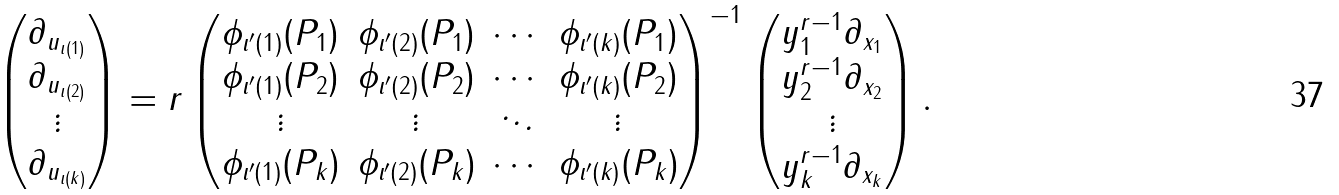<formula> <loc_0><loc_0><loc_500><loc_500>\left ( \begin{matrix} \partial _ { u _ { \iota ( 1 ) } } \\ \partial _ { u _ { \iota ( 2 ) } } \\ \vdots \\ \partial _ { u _ { \iota ( k ) } } \end{matrix} \right ) = r \left ( \begin{matrix} \phi _ { \iota ^ { \prime } ( 1 ) } ( P _ { 1 } ) & \phi _ { \iota ^ { \prime } ( 2 ) } ( P _ { 1 } ) & \cdots & \phi _ { \iota ^ { \prime } ( k ) } ( P _ { 1 } ) \\ \phi _ { \iota ^ { \prime } ( 1 ) } ( P _ { 2 } ) & \phi _ { \iota ^ { \prime } ( 2 ) } ( P _ { 2 } ) & \cdots & \phi _ { \iota ^ { \prime } ( k ) } ( P _ { 2 } ) \\ \vdots & \vdots & \ddots & \vdots \\ \phi _ { \iota ^ { \prime } ( 1 ) } ( P _ { k } ) & \phi _ { \iota ^ { \prime } ( 2 ) } ( P _ { k } ) & \cdots & \phi _ { \iota ^ { \prime } ( k ) } ( P _ { k } ) \end{matrix} \right ) ^ { - 1 } \left ( \begin{matrix} y ^ { r - 1 } _ { 1 } \partial _ { x _ { 1 } } \\ y ^ { r - 1 } _ { 2 } \partial _ { x _ { 2 } } \\ \vdots \\ y ^ { r - 1 } _ { k } \partial _ { x _ { k } } \end{matrix} \right ) .</formula> 